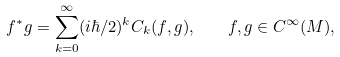Convert formula to latex. <formula><loc_0><loc_0><loc_500><loc_500>f ^ { * } g = \sum _ { k = 0 } ^ { \infty } ( i \hbar { / } 2 ) ^ { k } C _ { k } ( f , g ) , \quad f , g \in C ^ { \infty } ( M ) ,</formula> 